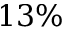Convert formula to latex. <formula><loc_0><loc_0><loc_500><loc_500>1 3 \%</formula> 